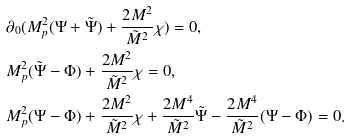<formula> <loc_0><loc_0><loc_500><loc_500>& \partial _ { 0 } ( M _ { p } ^ { 2 } ( \Psi + \tilde { \Psi } ) + \frac { 2 M ^ { 2 } } { \tilde { M } ^ { 2 } } \chi ) = 0 , \\ & M _ { p } ^ { 2 } ( \tilde { \Psi } - \Phi ) + \frac { 2 M ^ { 2 } } { \tilde { M } ^ { 2 } } \chi = 0 , \\ & M _ { p } ^ { 2 } ( \Psi - \Phi ) + \frac { 2 M ^ { 2 } } { \tilde { M } ^ { 2 } } \chi + \frac { 2 M ^ { 4 } } { \tilde { M } ^ { 2 } } \tilde { \Psi } - \frac { 2 M ^ { 4 } } { \tilde { M } ^ { 2 } } ( \Psi - \Phi ) = 0 .</formula> 